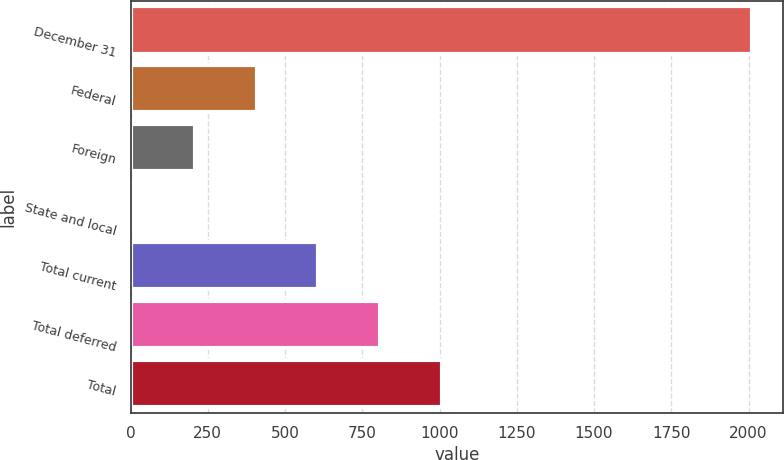<chart> <loc_0><loc_0><loc_500><loc_500><bar_chart><fcel>December 31<fcel>Federal<fcel>Foreign<fcel>State and local<fcel>Total current<fcel>Total deferred<fcel>Total<nl><fcel>2011<fcel>407.8<fcel>207.4<fcel>7<fcel>608.2<fcel>808.6<fcel>1009<nl></chart> 